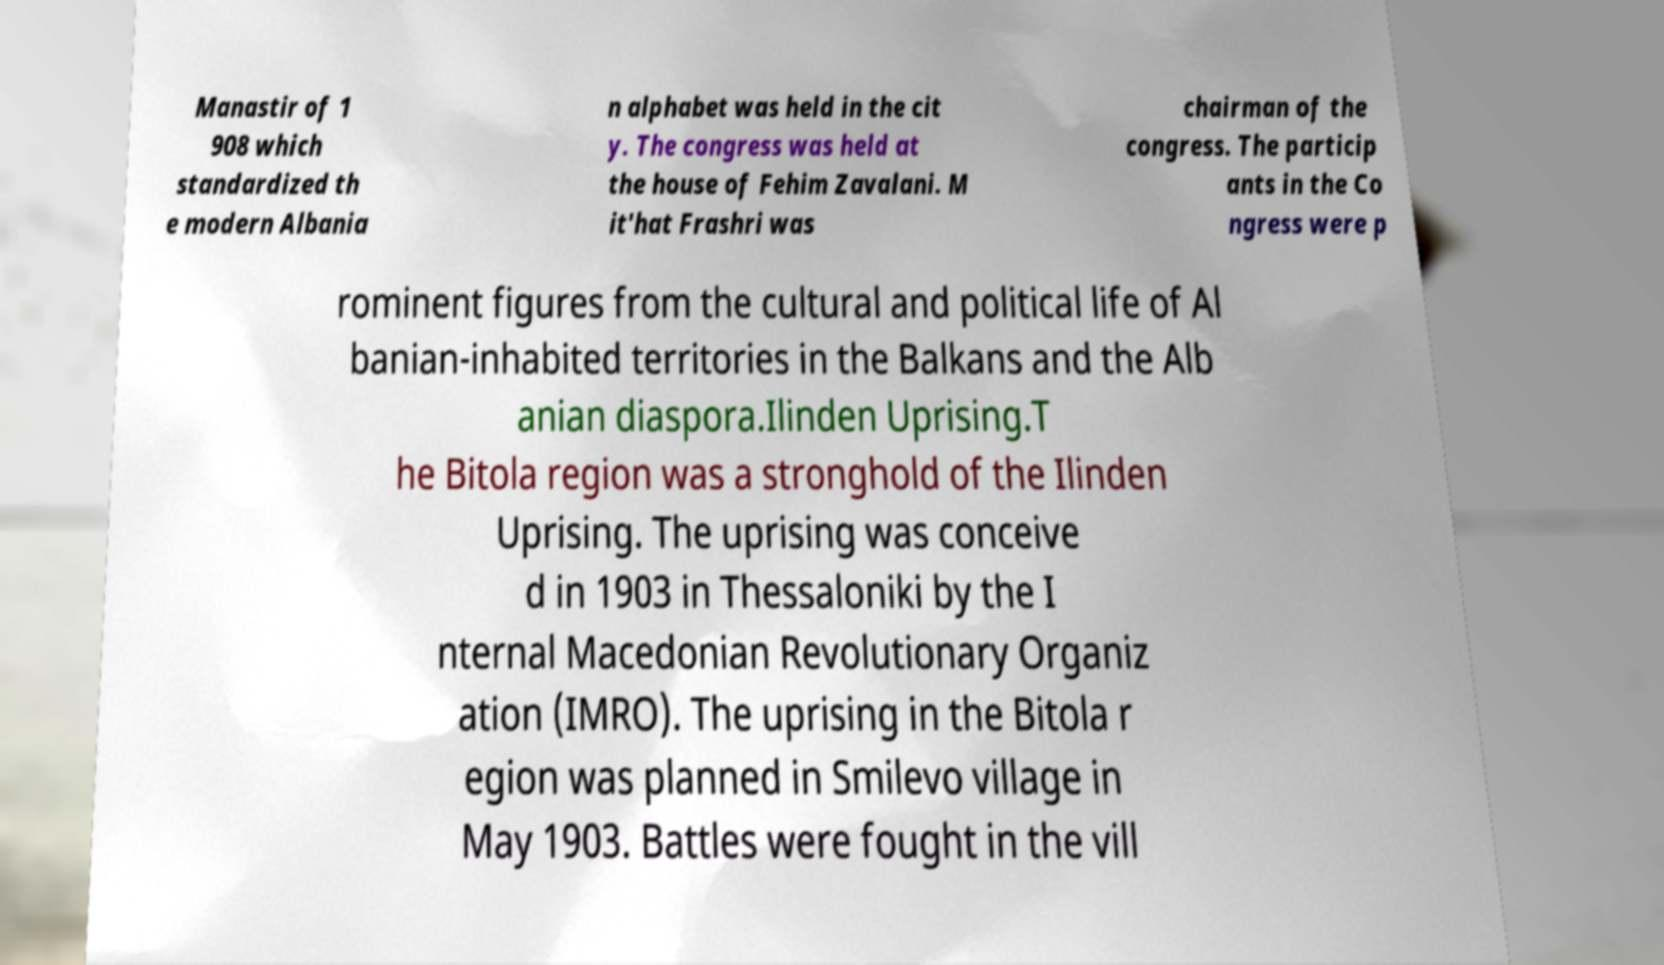Please read and relay the text visible in this image. What does it say? Manastir of 1 908 which standardized th e modern Albania n alphabet was held in the cit y. The congress was held at the house of Fehim Zavalani. M it'hat Frashri was chairman of the congress. The particip ants in the Co ngress were p rominent figures from the cultural and political life of Al banian-inhabited territories in the Balkans and the Alb anian diaspora.Ilinden Uprising.T he Bitola region was a stronghold of the Ilinden Uprising. The uprising was conceive d in 1903 in Thessaloniki by the I nternal Macedonian Revolutionary Organiz ation (IMRO). The uprising in the Bitola r egion was planned in Smilevo village in May 1903. Battles were fought in the vill 